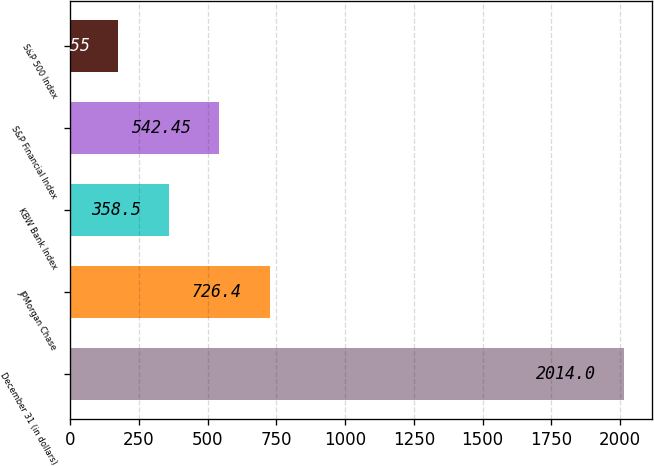Convert chart to OTSL. <chart><loc_0><loc_0><loc_500><loc_500><bar_chart><fcel>December 31 (in dollars)<fcel>JPMorgan Chase<fcel>KBW Bank Index<fcel>S&P Financial Index<fcel>S&P 500 Index<nl><fcel>2014<fcel>726.4<fcel>358.5<fcel>542.45<fcel>174.55<nl></chart> 